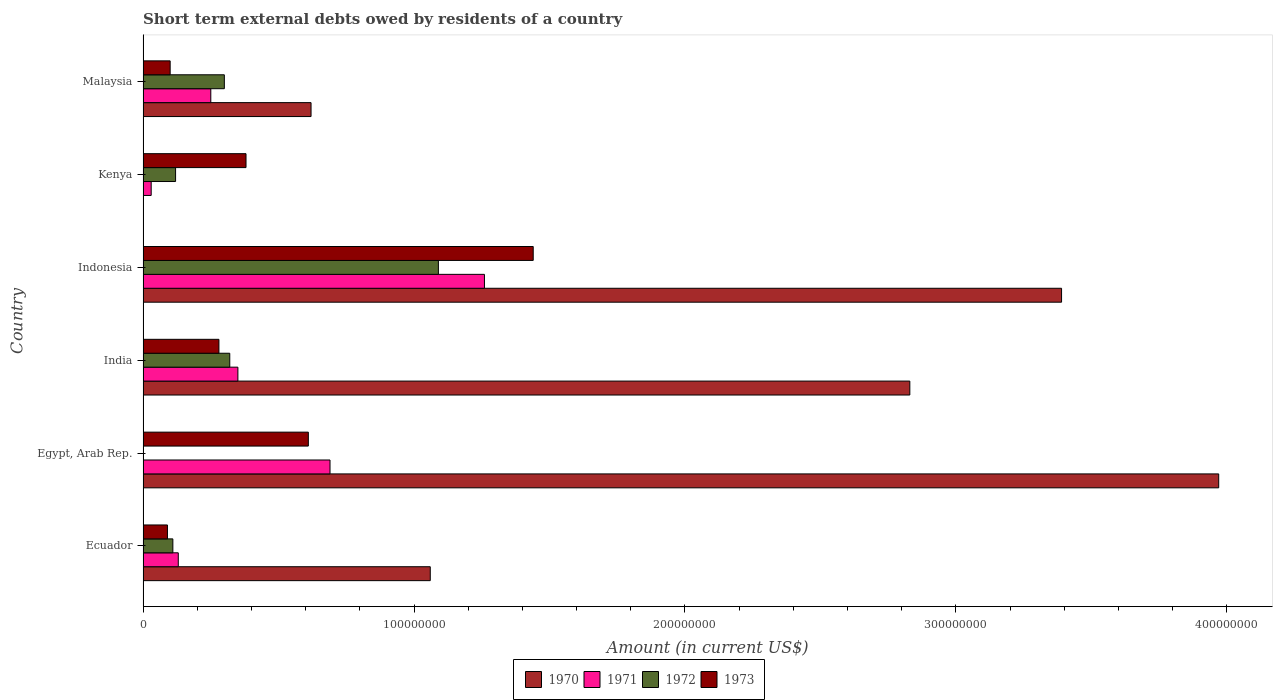How many different coloured bars are there?
Your response must be concise. 4. How many groups of bars are there?
Ensure brevity in your answer.  6. Are the number of bars on each tick of the Y-axis equal?
Offer a terse response. No. What is the label of the 2nd group of bars from the top?
Provide a succinct answer. Kenya. What is the amount of short-term external debts owed by residents in 1972 in Malaysia?
Your answer should be compact. 3.00e+07. Across all countries, what is the maximum amount of short-term external debts owed by residents in 1970?
Your response must be concise. 3.97e+08. What is the total amount of short-term external debts owed by residents in 1973 in the graph?
Make the answer very short. 2.90e+08. What is the difference between the amount of short-term external debts owed by residents in 1972 in Ecuador and that in Malaysia?
Your response must be concise. -1.90e+07. What is the difference between the amount of short-term external debts owed by residents in 1970 in India and the amount of short-term external debts owed by residents in 1971 in Ecuador?
Your answer should be compact. 2.70e+08. What is the average amount of short-term external debts owed by residents in 1971 per country?
Offer a terse response. 4.52e+07. What is the difference between the amount of short-term external debts owed by residents in 1971 and amount of short-term external debts owed by residents in 1972 in Indonesia?
Keep it short and to the point. 1.70e+07. What is the ratio of the amount of short-term external debts owed by residents in 1973 in India to that in Kenya?
Keep it short and to the point. 0.74. Is the difference between the amount of short-term external debts owed by residents in 1971 in India and Kenya greater than the difference between the amount of short-term external debts owed by residents in 1972 in India and Kenya?
Offer a terse response. Yes. What is the difference between the highest and the second highest amount of short-term external debts owed by residents in 1971?
Your response must be concise. 5.70e+07. What is the difference between the highest and the lowest amount of short-term external debts owed by residents in 1973?
Offer a very short reply. 1.35e+08. In how many countries, is the amount of short-term external debts owed by residents in 1971 greater than the average amount of short-term external debts owed by residents in 1971 taken over all countries?
Ensure brevity in your answer.  2. Is it the case that in every country, the sum of the amount of short-term external debts owed by residents in 1973 and amount of short-term external debts owed by residents in 1971 is greater than the amount of short-term external debts owed by residents in 1972?
Your answer should be very brief. Yes. How many bars are there?
Ensure brevity in your answer.  22. Are all the bars in the graph horizontal?
Keep it short and to the point. Yes. Are the values on the major ticks of X-axis written in scientific E-notation?
Keep it short and to the point. No. Does the graph contain any zero values?
Offer a very short reply. Yes. Does the graph contain grids?
Offer a very short reply. No. How many legend labels are there?
Provide a short and direct response. 4. How are the legend labels stacked?
Your answer should be compact. Horizontal. What is the title of the graph?
Ensure brevity in your answer.  Short term external debts owed by residents of a country. Does "2004" appear as one of the legend labels in the graph?
Your answer should be very brief. No. What is the label or title of the X-axis?
Your answer should be very brief. Amount (in current US$). What is the label or title of the Y-axis?
Make the answer very short. Country. What is the Amount (in current US$) in 1970 in Ecuador?
Make the answer very short. 1.06e+08. What is the Amount (in current US$) in 1971 in Ecuador?
Your answer should be very brief. 1.30e+07. What is the Amount (in current US$) of 1972 in Ecuador?
Provide a short and direct response. 1.10e+07. What is the Amount (in current US$) in 1973 in Ecuador?
Offer a terse response. 9.00e+06. What is the Amount (in current US$) of 1970 in Egypt, Arab Rep.?
Keep it short and to the point. 3.97e+08. What is the Amount (in current US$) of 1971 in Egypt, Arab Rep.?
Make the answer very short. 6.90e+07. What is the Amount (in current US$) in 1973 in Egypt, Arab Rep.?
Keep it short and to the point. 6.10e+07. What is the Amount (in current US$) of 1970 in India?
Your response must be concise. 2.83e+08. What is the Amount (in current US$) of 1971 in India?
Give a very brief answer. 3.50e+07. What is the Amount (in current US$) in 1972 in India?
Your answer should be very brief. 3.20e+07. What is the Amount (in current US$) in 1973 in India?
Ensure brevity in your answer.  2.80e+07. What is the Amount (in current US$) in 1970 in Indonesia?
Your answer should be very brief. 3.39e+08. What is the Amount (in current US$) of 1971 in Indonesia?
Your response must be concise. 1.26e+08. What is the Amount (in current US$) of 1972 in Indonesia?
Offer a terse response. 1.09e+08. What is the Amount (in current US$) of 1973 in Indonesia?
Provide a short and direct response. 1.44e+08. What is the Amount (in current US$) of 1970 in Kenya?
Keep it short and to the point. 0. What is the Amount (in current US$) of 1971 in Kenya?
Provide a succinct answer. 3.00e+06. What is the Amount (in current US$) of 1973 in Kenya?
Ensure brevity in your answer.  3.80e+07. What is the Amount (in current US$) in 1970 in Malaysia?
Make the answer very short. 6.20e+07. What is the Amount (in current US$) in 1971 in Malaysia?
Provide a succinct answer. 2.50e+07. What is the Amount (in current US$) in 1972 in Malaysia?
Offer a very short reply. 3.00e+07. Across all countries, what is the maximum Amount (in current US$) of 1970?
Your answer should be compact. 3.97e+08. Across all countries, what is the maximum Amount (in current US$) of 1971?
Give a very brief answer. 1.26e+08. Across all countries, what is the maximum Amount (in current US$) of 1972?
Make the answer very short. 1.09e+08. Across all countries, what is the maximum Amount (in current US$) in 1973?
Make the answer very short. 1.44e+08. Across all countries, what is the minimum Amount (in current US$) of 1973?
Your response must be concise. 9.00e+06. What is the total Amount (in current US$) in 1970 in the graph?
Keep it short and to the point. 1.19e+09. What is the total Amount (in current US$) in 1971 in the graph?
Your answer should be very brief. 2.71e+08. What is the total Amount (in current US$) of 1972 in the graph?
Offer a terse response. 1.94e+08. What is the total Amount (in current US$) of 1973 in the graph?
Provide a short and direct response. 2.90e+08. What is the difference between the Amount (in current US$) in 1970 in Ecuador and that in Egypt, Arab Rep.?
Ensure brevity in your answer.  -2.91e+08. What is the difference between the Amount (in current US$) in 1971 in Ecuador and that in Egypt, Arab Rep.?
Provide a succinct answer. -5.60e+07. What is the difference between the Amount (in current US$) in 1973 in Ecuador and that in Egypt, Arab Rep.?
Offer a terse response. -5.20e+07. What is the difference between the Amount (in current US$) of 1970 in Ecuador and that in India?
Provide a succinct answer. -1.77e+08. What is the difference between the Amount (in current US$) of 1971 in Ecuador and that in India?
Offer a very short reply. -2.20e+07. What is the difference between the Amount (in current US$) in 1972 in Ecuador and that in India?
Make the answer very short. -2.10e+07. What is the difference between the Amount (in current US$) in 1973 in Ecuador and that in India?
Your answer should be compact. -1.90e+07. What is the difference between the Amount (in current US$) of 1970 in Ecuador and that in Indonesia?
Provide a short and direct response. -2.33e+08. What is the difference between the Amount (in current US$) in 1971 in Ecuador and that in Indonesia?
Give a very brief answer. -1.13e+08. What is the difference between the Amount (in current US$) in 1972 in Ecuador and that in Indonesia?
Provide a short and direct response. -9.80e+07. What is the difference between the Amount (in current US$) in 1973 in Ecuador and that in Indonesia?
Provide a short and direct response. -1.35e+08. What is the difference between the Amount (in current US$) of 1972 in Ecuador and that in Kenya?
Keep it short and to the point. -1.00e+06. What is the difference between the Amount (in current US$) in 1973 in Ecuador and that in Kenya?
Your answer should be very brief. -2.90e+07. What is the difference between the Amount (in current US$) of 1970 in Ecuador and that in Malaysia?
Offer a very short reply. 4.40e+07. What is the difference between the Amount (in current US$) of 1971 in Ecuador and that in Malaysia?
Provide a short and direct response. -1.20e+07. What is the difference between the Amount (in current US$) of 1972 in Ecuador and that in Malaysia?
Your response must be concise. -1.90e+07. What is the difference between the Amount (in current US$) in 1973 in Ecuador and that in Malaysia?
Your response must be concise. -1.00e+06. What is the difference between the Amount (in current US$) of 1970 in Egypt, Arab Rep. and that in India?
Your answer should be very brief. 1.14e+08. What is the difference between the Amount (in current US$) in 1971 in Egypt, Arab Rep. and that in India?
Your answer should be compact. 3.40e+07. What is the difference between the Amount (in current US$) of 1973 in Egypt, Arab Rep. and that in India?
Your answer should be compact. 3.30e+07. What is the difference between the Amount (in current US$) in 1970 in Egypt, Arab Rep. and that in Indonesia?
Your response must be concise. 5.80e+07. What is the difference between the Amount (in current US$) of 1971 in Egypt, Arab Rep. and that in Indonesia?
Your answer should be very brief. -5.70e+07. What is the difference between the Amount (in current US$) of 1973 in Egypt, Arab Rep. and that in Indonesia?
Your answer should be very brief. -8.30e+07. What is the difference between the Amount (in current US$) of 1971 in Egypt, Arab Rep. and that in Kenya?
Ensure brevity in your answer.  6.60e+07. What is the difference between the Amount (in current US$) in 1973 in Egypt, Arab Rep. and that in Kenya?
Give a very brief answer. 2.30e+07. What is the difference between the Amount (in current US$) of 1970 in Egypt, Arab Rep. and that in Malaysia?
Your answer should be compact. 3.35e+08. What is the difference between the Amount (in current US$) in 1971 in Egypt, Arab Rep. and that in Malaysia?
Offer a very short reply. 4.40e+07. What is the difference between the Amount (in current US$) of 1973 in Egypt, Arab Rep. and that in Malaysia?
Your answer should be compact. 5.10e+07. What is the difference between the Amount (in current US$) of 1970 in India and that in Indonesia?
Make the answer very short. -5.60e+07. What is the difference between the Amount (in current US$) of 1971 in India and that in Indonesia?
Make the answer very short. -9.10e+07. What is the difference between the Amount (in current US$) of 1972 in India and that in Indonesia?
Make the answer very short. -7.70e+07. What is the difference between the Amount (in current US$) of 1973 in India and that in Indonesia?
Provide a succinct answer. -1.16e+08. What is the difference between the Amount (in current US$) in 1971 in India and that in Kenya?
Provide a short and direct response. 3.20e+07. What is the difference between the Amount (in current US$) in 1972 in India and that in Kenya?
Keep it short and to the point. 2.00e+07. What is the difference between the Amount (in current US$) in 1973 in India and that in Kenya?
Your response must be concise. -1.00e+07. What is the difference between the Amount (in current US$) of 1970 in India and that in Malaysia?
Offer a very short reply. 2.21e+08. What is the difference between the Amount (in current US$) of 1972 in India and that in Malaysia?
Your answer should be compact. 2.00e+06. What is the difference between the Amount (in current US$) of 1973 in India and that in Malaysia?
Your answer should be very brief. 1.80e+07. What is the difference between the Amount (in current US$) of 1971 in Indonesia and that in Kenya?
Ensure brevity in your answer.  1.23e+08. What is the difference between the Amount (in current US$) of 1972 in Indonesia and that in Kenya?
Make the answer very short. 9.70e+07. What is the difference between the Amount (in current US$) of 1973 in Indonesia and that in Kenya?
Provide a short and direct response. 1.06e+08. What is the difference between the Amount (in current US$) in 1970 in Indonesia and that in Malaysia?
Ensure brevity in your answer.  2.77e+08. What is the difference between the Amount (in current US$) of 1971 in Indonesia and that in Malaysia?
Provide a succinct answer. 1.01e+08. What is the difference between the Amount (in current US$) of 1972 in Indonesia and that in Malaysia?
Ensure brevity in your answer.  7.90e+07. What is the difference between the Amount (in current US$) in 1973 in Indonesia and that in Malaysia?
Your response must be concise. 1.34e+08. What is the difference between the Amount (in current US$) of 1971 in Kenya and that in Malaysia?
Give a very brief answer. -2.20e+07. What is the difference between the Amount (in current US$) in 1972 in Kenya and that in Malaysia?
Your response must be concise. -1.80e+07. What is the difference between the Amount (in current US$) of 1973 in Kenya and that in Malaysia?
Keep it short and to the point. 2.80e+07. What is the difference between the Amount (in current US$) of 1970 in Ecuador and the Amount (in current US$) of 1971 in Egypt, Arab Rep.?
Offer a terse response. 3.70e+07. What is the difference between the Amount (in current US$) of 1970 in Ecuador and the Amount (in current US$) of 1973 in Egypt, Arab Rep.?
Make the answer very short. 4.50e+07. What is the difference between the Amount (in current US$) in 1971 in Ecuador and the Amount (in current US$) in 1973 in Egypt, Arab Rep.?
Your response must be concise. -4.80e+07. What is the difference between the Amount (in current US$) of 1972 in Ecuador and the Amount (in current US$) of 1973 in Egypt, Arab Rep.?
Keep it short and to the point. -5.00e+07. What is the difference between the Amount (in current US$) of 1970 in Ecuador and the Amount (in current US$) of 1971 in India?
Make the answer very short. 7.10e+07. What is the difference between the Amount (in current US$) in 1970 in Ecuador and the Amount (in current US$) in 1972 in India?
Offer a very short reply. 7.40e+07. What is the difference between the Amount (in current US$) in 1970 in Ecuador and the Amount (in current US$) in 1973 in India?
Your response must be concise. 7.80e+07. What is the difference between the Amount (in current US$) of 1971 in Ecuador and the Amount (in current US$) of 1972 in India?
Ensure brevity in your answer.  -1.90e+07. What is the difference between the Amount (in current US$) of 1971 in Ecuador and the Amount (in current US$) of 1973 in India?
Your response must be concise. -1.50e+07. What is the difference between the Amount (in current US$) of 1972 in Ecuador and the Amount (in current US$) of 1973 in India?
Offer a very short reply. -1.70e+07. What is the difference between the Amount (in current US$) in 1970 in Ecuador and the Amount (in current US$) in 1971 in Indonesia?
Provide a succinct answer. -2.00e+07. What is the difference between the Amount (in current US$) of 1970 in Ecuador and the Amount (in current US$) of 1973 in Indonesia?
Offer a terse response. -3.80e+07. What is the difference between the Amount (in current US$) of 1971 in Ecuador and the Amount (in current US$) of 1972 in Indonesia?
Give a very brief answer. -9.60e+07. What is the difference between the Amount (in current US$) of 1971 in Ecuador and the Amount (in current US$) of 1973 in Indonesia?
Make the answer very short. -1.31e+08. What is the difference between the Amount (in current US$) in 1972 in Ecuador and the Amount (in current US$) in 1973 in Indonesia?
Your answer should be compact. -1.33e+08. What is the difference between the Amount (in current US$) in 1970 in Ecuador and the Amount (in current US$) in 1971 in Kenya?
Give a very brief answer. 1.03e+08. What is the difference between the Amount (in current US$) in 1970 in Ecuador and the Amount (in current US$) in 1972 in Kenya?
Offer a terse response. 9.40e+07. What is the difference between the Amount (in current US$) in 1970 in Ecuador and the Amount (in current US$) in 1973 in Kenya?
Ensure brevity in your answer.  6.80e+07. What is the difference between the Amount (in current US$) in 1971 in Ecuador and the Amount (in current US$) in 1972 in Kenya?
Your answer should be very brief. 1.00e+06. What is the difference between the Amount (in current US$) of 1971 in Ecuador and the Amount (in current US$) of 1973 in Kenya?
Provide a succinct answer. -2.50e+07. What is the difference between the Amount (in current US$) in 1972 in Ecuador and the Amount (in current US$) in 1973 in Kenya?
Offer a very short reply. -2.70e+07. What is the difference between the Amount (in current US$) of 1970 in Ecuador and the Amount (in current US$) of 1971 in Malaysia?
Your response must be concise. 8.10e+07. What is the difference between the Amount (in current US$) of 1970 in Ecuador and the Amount (in current US$) of 1972 in Malaysia?
Ensure brevity in your answer.  7.60e+07. What is the difference between the Amount (in current US$) in 1970 in Ecuador and the Amount (in current US$) in 1973 in Malaysia?
Ensure brevity in your answer.  9.60e+07. What is the difference between the Amount (in current US$) of 1971 in Ecuador and the Amount (in current US$) of 1972 in Malaysia?
Keep it short and to the point. -1.70e+07. What is the difference between the Amount (in current US$) in 1970 in Egypt, Arab Rep. and the Amount (in current US$) in 1971 in India?
Offer a terse response. 3.62e+08. What is the difference between the Amount (in current US$) in 1970 in Egypt, Arab Rep. and the Amount (in current US$) in 1972 in India?
Make the answer very short. 3.65e+08. What is the difference between the Amount (in current US$) in 1970 in Egypt, Arab Rep. and the Amount (in current US$) in 1973 in India?
Your response must be concise. 3.69e+08. What is the difference between the Amount (in current US$) of 1971 in Egypt, Arab Rep. and the Amount (in current US$) of 1972 in India?
Your response must be concise. 3.70e+07. What is the difference between the Amount (in current US$) in 1971 in Egypt, Arab Rep. and the Amount (in current US$) in 1973 in India?
Offer a terse response. 4.10e+07. What is the difference between the Amount (in current US$) of 1970 in Egypt, Arab Rep. and the Amount (in current US$) of 1971 in Indonesia?
Your answer should be very brief. 2.71e+08. What is the difference between the Amount (in current US$) of 1970 in Egypt, Arab Rep. and the Amount (in current US$) of 1972 in Indonesia?
Give a very brief answer. 2.88e+08. What is the difference between the Amount (in current US$) of 1970 in Egypt, Arab Rep. and the Amount (in current US$) of 1973 in Indonesia?
Your answer should be compact. 2.53e+08. What is the difference between the Amount (in current US$) of 1971 in Egypt, Arab Rep. and the Amount (in current US$) of 1972 in Indonesia?
Provide a short and direct response. -4.00e+07. What is the difference between the Amount (in current US$) in 1971 in Egypt, Arab Rep. and the Amount (in current US$) in 1973 in Indonesia?
Keep it short and to the point. -7.50e+07. What is the difference between the Amount (in current US$) in 1970 in Egypt, Arab Rep. and the Amount (in current US$) in 1971 in Kenya?
Give a very brief answer. 3.94e+08. What is the difference between the Amount (in current US$) in 1970 in Egypt, Arab Rep. and the Amount (in current US$) in 1972 in Kenya?
Your response must be concise. 3.85e+08. What is the difference between the Amount (in current US$) in 1970 in Egypt, Arab Rep. and the Amount (in current US$) in 1973 in Kenya?
Give a very brief answer. 3.59e+08. What is the difference between the Amount (in current US$) of 1971 in Egypt, Arab Rep. and the Amount (in current US$) of 1972 in Kenya?
Your answer should be very brief. 5.70e+07. What is the difference between the Amount (in current US$) of 1971 in Egypt, Arab Rep. and the Amount (in current US$) of 1973 in Kenya?
Offer a very short reply. 3.10e+07. What is the difference between the Amount (in current US$) in 1970 in Egypt, Arab Rep. and the Amount (in current US$) in 1971 in Malaysia?
Make the answer very short. 3.72e+08. What is the difference between the Amount (in current US$) of 1970 in Egypt, Arab Rep. and the Amount (in current US$) of 1972 in Malaysia?
Give a very brief answer. 3.67e+08. What is the difference between the Amount (in current US$) in 1970 in Egypt, Arab Rep. and the Amount (in current US$) in 1973 in Malaysia?
Give a very brief answer. 3.87e+08. What is the difference between the Amount (in current US$) in 1971 in Egypt, Arab Rep. and the Amount (in current US$) in 1972 in Malaysia?
Your answer should be very brief. 3.90e+07. What is the difference between the Amount (in current US$) of 1971 in Egypt, Arab Rep. and the Amount (in current US$) of 1973 in Malaysia?
Offer a very short reply. 5.90e+07. What is the difference between the Amount (in current US$) in 1970 in India and the Amount (in current US$) in 1971 in Indonesia?
Keep it short and to the point. 1.57e+08. What is the difference between the Amount (in current US$) of 1970 in India and the Amount (in current US$) of 1972 in Indonesia?
Provide a succinct answer. 1.74e+08. What is the difference between the Amount (in current US$) in 1970 in India and the Amount (in current US$) in 1973 in Indonesia?
Your answer should be compact. 1.39e+08. What is the difference between the Amount (in current US$) in 1971 in India and the Amount (in current US$) in 1972 in Indonesia?
Your answer should be very brief. -7.40e+07. What is the difference between the Amount (in current US$) of 1971 in India and the Amount (in current US$) of 1973 in Indonesia?
Your response must be concise. -1.09e+08. What is the difference between the Amount (in current US$) of 1972 in India and the Amount (in current US$) of 1973 in Indonesia?
Provide a succinct answer. -1.12e+08. What is the difference between the Amount (in current US$) in 1970 in India and the Amount (in current US$) in 1971 in Kenya?
Make the answer very short. 2.80e+08. What is the difference between the Amount (in current US$) of 1970 in India and the Amount (in current US$) of 1972 in Kenya?
Provide a short and direct response. 2.71e+08. What is the difference between the Amount (in current US$) in 1970 in India and the Amount (in current US$) in 1973 in Kenya?
Offer a terse response. 2.45e+08. What is the difference between the Amount (in current US$) in 1971 in India and the Amount (in current US$) in 1972 in Kenya?
Your answer should be compact. 2.30e+07. What is the difference between the Amount (in current US$) of 1972 in India and the Amount (in current US$) of 1973 in Kenya?
Keep it short and to the point. -6.00e+06. What is the difference between the Amount (in current US$) of 1970 in India and the Amount (in current US$) of 1971 in Malaysia?
Keep it short and to the point. 2.58e+08. What is the difference between the Amount (in current US$) in 1970 in India and the Amount (in current US$) in 1972 in Malaysia?
Ensure brevity in your answer.  2.53e+08. What is the difference between the Amount (in current US$) in 1970 in India and the Amount (in current US$) in 1973 in Malaysia?
Make the answer very short. 2.73e+08. What is the difference between the Amount (in current US$) in 1971 in India and the Amount (in current US$) in 1973 in Malaysia?
Ensure brevity in your answer.  2.50e+07. What is the difference between the Amount (in current US$) in 1972 in India and the Amount (in current US$) in 1973 in Malaysia?
Provide a succinct answer. 2.20e+07. What is the difference between the Amount (in current US$) in 1970 in Indonesia and the Amount (in current US$) in 1971 in Kenya?
Make the answer very short. 3.36e+08. What is the difference between the Amount (in current US$) in 1970 in Indonesia and the Amount (in current US$) in 1972 in Kenya?
Provide a succinct answer. 3.27e+08. What is the difference between the Amount (in current US$) of 1970 in Indonesia and the Amount (in current US$) of 1973 in Kenya?
Offer a terse response. 3.01e+08. What is the difference between the Amount (in current US$) in 1971 in Indonesia and the Amount (in current US$) in 1972 in Kenya?
Ensure brevity in your answer.  1.14e+08. What is the difference between the Amount (in current US$) of 1971 in Indonesia and the Amount (in current US$) of 1973 in Kenya?
Provide a short and direct response. 8.80e+07. What is the difference between the Amount (in current US$) of 1972 in Indonesia and the Amount (in current US$) of 1973 in Kenya?
Offer a very short reply. 7.10e+07. What is the difference between the Amount (in current US$) in 1970 in Indonesia and the Amount (in current US$) in 1971 in Malaysia?
Your answer should be compact. 3.14e+08. What is the difference between the Amount (in current US$) of 1970 in Indonesia and the Amount (in current US$) of 1972 in Malaysia?
Your answer should be compact. 3.09e+08. What is the difference between the Amount (in current US$) of 1970 in Indonesia and the Amount (in current US$) of 1973 in Malaysia?
Provide a short and direct response. 3.29e+08. What is the difference between the Amount (in current US$) in 1971 in Indonesia and the Amount (in current US$) in 1972 in Malaysia?
Your answer should be very brief. 9.60e+07. What is the difference between the Amount (in current US$) of 1971 in Indonesia and the Amount (in current US$) of 1973 in Malaysia?
Your answer should be compact. 1.16e+08. What is the difference between the Amount (in current US$) of 1972 in Indonesia and the Amount (in current US$) of 1973 in Malaysia?
Make the answer very short. 9.90e+07. What is the difference between the Amount (in current US$) of 1971 in Kenya and the Amount (in current US$) of 1972 in Malaysia?
Provide a short and direct response. -2.70e+07. What is the difference between the Amount (in current US$) of 1971 in Kenya and the Amount (in current US$) of 1973 in Malaysia?
Keep it short and to the point. -7.00e+06. What is the average Amount (in current US$) of 1970 per country?
Your answer should be compact. 1.98e+08. What is the average Amount (in current US$) in 1971 per country?
Ensure brevity in your answer.  4.52e+07. What is the average Amount (in current US$) of 1972 per country?
Make the answer very short. 3.23e+07. What is the average Amount (in current US$) of 1973 per country?
Provide a short and direct response. 4.83e+07. What is the difference between the Amount (in current US$) of 1970 and Amount (in current US$) of 1971 in Ecuador?
Your response must be concise. 9.30e+07. What is the difference between the Amount (in current US$) of 1970 and Amount (in current US$) of 1972 in Ecuador?
Offer a very short reply. 9.50e+07. What is the difference between the Amount (in current US$) in 1970 and Amount (in current US$) in 1973 in Ecuador?
Offer a terse response. 9.70e+07. What is the difference between the Amount (in current US$) of 1971 and Amount (in current US$) of 1972 in Ecuador?
Provide a succinct answer. 2.00e+06. What is the difference between the Amount (in current US$) of 1971 and Amount (in current US$) of 1973 in Ecuador?
Offer a terse response. 4.00e+06. What is the difference between the Amount (in current US$) of 1970 and Amount (in current US$) of 1971 in Egypt, Arab Rep.?
Give a very brief answer. 3.28e+08. What is the difference between the Amount (in current US$) of 1970 and Amount (in current US$) of 1973 in Egypt, Arab Rep.?
Offer a very short reply. 3.36e+08. What is the difference between the Amount (in current US$) of 1970 and Amount (in current US$) of 1971 in India?
Provide a short and direct response. 2.48e+08. What is the difference between the Amount (in current US$) of 1970 and Amount (in current US$) of 1972 in India?
Your answer should be compact. 2.51e+08. What is the difference between the Amount (in current US$) in 1970 and Amount (in current US$) in 1973 in India?
Offer a very short reply. 2.55e+08. What is the difference between the Amount (in current US$) in 1971 and Amount (in current US$) in 1972 in India?
Offer a very short reply. 3.00e+06. What is the difference between the Amount (in current US$) of 1971 and Amount (in current US$) of 1973 in India?
Your response must be concise. 7.00e+06. What is the difference between the Amount (in current US$) in 1972 and Amount (in current US$) in 1973 in India?
Your answer should be very brief. 4.00e+06. What is the difference between the Amount (in current US$) in 1970 and Amount (in current US$) in 1971 in Indonesia?
Your response must be concise. 2.13e+08. What is the difference between the Amount (in current US$) of 1970 and Amount (in current US$) of 1972 in Indonesia?
Provide a succinct answer. 2.30e+08. What is the difference between the Amount (in current US$) in 1970 and Amount (in current US$) in 1973 in Indonesia?
Provide a short and direct response. 1.95e+08. What is the difference between the Amount (in current US$) in 1971 and Amount (in current US$) in 1972 in Indonesia?
Provide a short and direct response. 1.70e+07. What is the difference between the Amount (in current US$) of 1971 and Amount (in current US$) of 1973 in Indonesia?
Keep it short and to the point. -1.80e+07. What is the difference between the Amount (in current US$) of 1972 and Amount (in current US$) of 1973 in Indonesia?
Provide a short and direct response. -3.50e+07. What is the difference between the Amount (in current US$) of 1971 and Amount (in current US$) of 1972 in Kenya?
Give a very brief answer. -9.00e+06. What is the difference between the Amount (in current US$) of 1971 and Amount (in current US$) of 1973 in Kenya?
Keep it short and to the point. -3.50e+07. What is the difference between the Amount (in current US$) of 1972 and Amount (in current US$) of 1973 in Kenya?
Make the answer very short. -2.60e+07. What is the difference between the Amount (in current US$) of 1970 and Amount (in current US$) of 1971 in Malaysia?
Make the answer very short. 3.70e+07. What is the difference between the Amount (in current US$) of 1970 and Amount (in current US$) of 1972 in Malaysia?
Provide a short and direct response. 3.20e+07. What is the difference between the Amount (in current US$) of 1970 and Amount (in current US$) of 1973 in Malaysia?
Give a very brief answer. 5.20e+07. What is the difference between the Amount (in current US$) in 1971 and Amount (in current US$) in 1972 in Malaysia?
Make the answer very short. -5.00e+06. What is the difference between the Amount (in current US$) in 1971 and Amount (in current US$) in 1973 in Malaysia?
Provide a succinct answer. 1.50e+07. What is the difference between the Amount (in current US$) in 1972 and Amount (in current US$) in 1973 in Malaysia?
Make the answer very short. 2.00e+07. What is the ratio of the Amount (in current US$) of 1970 in Ecuador to that in Egypt, Arab Rep.?
Your answer should be very brief. 0.27. What is the ratio of the Amount (in current US$) of 1971 in Ecuador to that in Egypt, Arab Rep.?
Your response must be concise. 0.19. What is the ratio of the Amount (in current US$) in 1973 in Ecuador to that in Egypt, Arab Rep.?
Make the answer very short. 0.15. What is the ratio of the Amount (in current US$) in 1970 in Ecuador to that in India?
Offer a terse response. 0.37. What is the ratio of the Amount (in current US$) of 1971 in Ecuador to that in India?
Ensure brevity in your answer.  0.37. What is the ratio of the Amount (in current US$) in 1972 in Ecuador to that in India?
Your response must be concise. 0.34. What is the ratio of the Amount (in current US$) in 1973 in Ecuador to that in India?
Provide a succinct answer. 0.32. What is the ratio of the Amount (in current US$) in 1970 in Ecuador to that in Indonesia?
Offer a very short reply. 0.31. What is the ratio of the Amount (in current US$) in 1971 in Ecuador to that in Indonesia?
Your answer should be compact. 0.1. What is the ratio of the Amount (in current US$) in 1972 in Ecuador to that in Indonesia?
Provide a short and direct response. 0.1. What is the ratio of the Amount (in current US$) of 1973 in Ecuador to that in Indonesia?
Provide a succinct answer. 0.06. What is the ratio of the Amount (in current US$) of 1971 in Ecuador to that in Kenya?
Your answer should be very brief. 4.33. What is the ratio of the Amount (in current US$) of 1973 in Ecuador to that in Kenya?
Your response must be concise. 0.24. What is the ratio of the Amount (in current US$) of 1970 in Ecuador to that in Malaysia?
Your answer should be compact. 1.71. What is the ratio of the Amount (in current US$) of 1971 in Ecuador to that in Malaysia?
Your response must be concise. 0.52. What is the ratio of the Amount (in current US$) of 1972 in Ecuador to that in Malaysia?
Offer a terse response. 0.37. What is the ratio of the Amount (in current US$) of 1970 in Egypt, Arab Rep. to that in India?
Provide a succinct answer. 1.4. What is the ratio of the Amount (in current US$) of 1971 in Egypt, Arab Rep. to that in India?
Provide a succinct answer. 1.97. What is the ratio of the Amount (in current US$) in 1973 in Egypt, Arab Rep. to that in India?
Your answer should be very brief. 2.18. What is the ratio of the Amount (in current US$) of 1970 in Egypt, Arab Rep. to that in Indonesia?
Offer a very short reply. 1.17. What is the ratio of the Amount (in current US$) of 1971 in Egypt, Arab Rep. to that in Indonesia?
Offer a terse response. 0.55. What is the ratio of the Amount (in current US$) of 1973 in Egypt, Arab Rep. to that in Indonesia?
Make the answer very short. 0.42. What is the ratio of the Amount (in current US$) of 1971 in Egypt, Arab Rep. to that in Kenya?
Your response must be concise. 23. What is the ratio of the Amount (in current US$) of 1973 in Egypt, Arab Rep. to that in Kenya?
Provide a short and direct response. 1.61. What is the ratio of the Amount (in current US$) of 1970 in Egypt, Arab Rep. to that in Malaysia?
Your answer should be compact. 6.4. What is the ratio of the Amount (in current US$) of 1971 in Egypt, Arab Rep. to that in Malaysia?
Offer a very short reply. 2.76. What is the ratio of the Amount (in current US$) of 1973 in Egypt, Arab Rep. to that in Malaysia?
Make the answer very short. 6.1. What is the ratio of the Amount (in current US$) in 1970 in India to that in Indonesia?
Provide a short and direct response. 0.83. What is the ratio of the Amount (in current US$) of 1971 in India to that in Indonesia?
Provide a succinct answer. 0.28. What is the ratio of the Amount (in current US$) in 1972 in India to that in Indonesia?
Ensure brevity in your answer.  0.29. What is the ratio of the Amount (in current US$) of 1973 in India to that in Indonesia?
Offer a terse response. 0.19. What is the ratio of the Amount (in current US$) in 1971 in India to that in Kenya?
Keep it short and to the point. 11.67. What is the ratio of the Amount (in current US$) in 1972 in India to that in Kenya?
Offer a terse response. 2.67. What is the ratio of the Amount (in current US$) in 1973 in India to that in Kenya?
Your answer should be very brief. 0.74. What is the ratio of the Amount (in current US$) of 1970 in India to that in Malaysia?
Ensure brevity in your answer.  4.56. What is the ratio of the Amount (in current US$) in 1971 in India to that in Malaysia?
Your answer should be very brief. 1.4. What is the ratio of the Amount (in current US$) of 1972 in India to that in Malaysia?
Ensure brevity in your answer.  1.07. What is the ratio of the Amount (in current US$) of 1973 in India to that in Malaysia?
Your response must be concise. 2.8. What is the ratio of the Amount (in current US$) of 1971 in Indonesia to that in Kenya?
Your answer should be compact. 42. What is the ratio of the Amount (in current US$) of 1972 in Indonesia to that in Kenya?
Your answer should be compact. 9.08. What is the ratio of the Amount (in current US$) in 1973 in Indonesia to that in Kenya?
Provide a short and direct response. 3.79. What is the ratio of the Amount (in current US$) in 1970 in Indonesia to that in Malaysia?
Offer a very short reply. 5.47. What is the ratio of the Amount (in current US$) in 1971 in Indonesia to that in Malaysia?
Offer a very short reply. 5.04. What is the ratio of the Amount (in current US$) of 1972 in Indonesia to that in Malaysia?
Provide a succinct answer. 3.63. What is the ratio of the Amount (in current US$) in 1973 in Indonesia to that in Malaysia?
Make the answer very short. 14.4. What is the ratio of the Amount (in current US$) of 1971 in Kenya to that in Malaysia?
Your answer should be compact. 0.12. What is the ratio of the Amount (in current US$) of 1972 in Kenya to that in Malaysia?
Your response must be concise. 0.4. What is the ratio of the Amount (in current US$) of 1973 in Kenya to that in Malaysia?
Your response must be concise. 3.8. What is the difference between the highest and the second highest Amount (in current US$) of 1970?
Provide a short and direct response. 5.80e+07. What is the difference between the highest and the second highest Amount (in current US$) of 1971?
Offer a terse response. 5.70e+07. What is the difference between the highest and the second highest Amount (in current US$) in 1972?
Your answer should be very brief. 7.70e+07. What is the difference between the highest and the second highest Amount (in current US$) of 1973?
Provide a short and direct response. 8.30e+07. What is the difference between the highest and the lowest Amount (in current US$) of 1970?
Give a very brief answer. 3.97e+08. What is the difference between the highest and the lowest Amount (in current US$) in 1971?
Your answer should be very brief. 1.23e+08. What is the difference between the highest and the lowest Amount (in current US$) of 1972?
Your answer should be compact. 1.09e+08. What is the difference between the highest and the lowest Amount (in current US$) in 1973?
Your answer should be compact. 1.35e+08. 